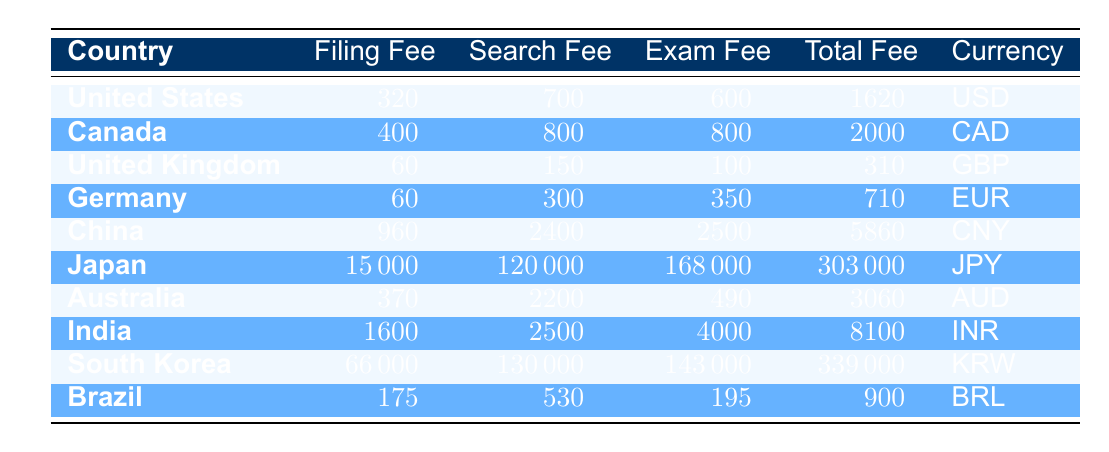What is the total patent filing fee in the United States? The total fee for filing a patent in the United States is found in the table under the "Total Fee" column next to the United States entry, which is 1620 USD.
Answer: 1620 USD Which country has the highest search fee? To determine which country has the highest search fee, we look at the "Search Fee" column, where the highest value is for Japan at 120000 JPY.
Answer: Japan What is the average total fee for patent filing across all listed countries? First, we sum the total fees: 1620 + 2000 + 310 + 710 + 5860 + 303000 + 3060 + 8100 + 339000 + 900 = 641060. There are 10 countries, so the average total fee is 641060 / 10 = 64106.0.
Answer: 64106.0 Is the patent filing fee in Brazil higher than in Germany? The filing fee in Brazil is 175 BRL and in Germany it is 60 EUR. Since 175 is greater than 60, the statement is true.
Answer: Yes What is the difference between the total fees in China and Brazil? The total fee in China is 5860 CNY and in Brazil it is 900 BRL. The difference is calculated as 5860 - 900 = 4960.
Answer: 4960 Which country has the least expensive total patent filing fee and what is the fee? By checking the "Total Fee" column, the lowest total fee listed is for the United Kingdom with a fee of 310 GBP.
Answer: United Kingdom, 310 GBP How much more is the total patent filing fee in Japan compared to Australia? The total fee in Japan is 303000 JPY, and in Australia, it is 3060 AUD. The difference, calculated as 303000 - 3060 = 299940, indicates Japan's fee is higher by this amount.
Answer: 299940 Did Canada have a lower total fee than the United Kingdom? The total fee in Canada is 2000 CAD while in the United Kingdom it is 310 GBP. Since 2000 is greater than 310, the statement is false.
Answer: No What is the total examination fee across all the countries? The examination fees listed for each country are 600 (US) + 800 (Canada) + 100 (UK) + 350 (Germany) + 2500 (China) + 168000 (Japan) + 490 (Australia) + 4000 (India) + 143000 (South Korea) + 195 (Brazil) = 315235.
Answer: 315235 